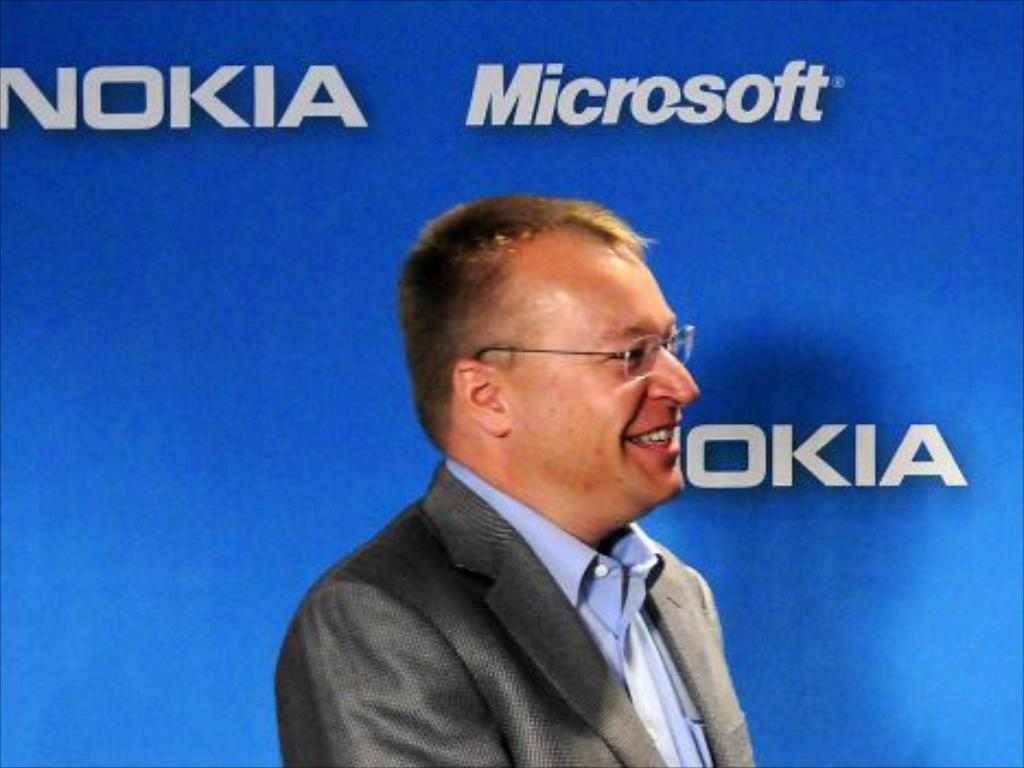<image>
Create a compact narrative representing the image presented. A man stands in front of a blue board with Nokia and Microsoft Printed on it. 